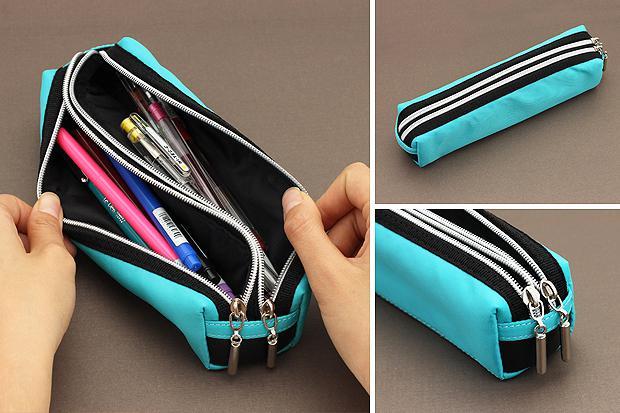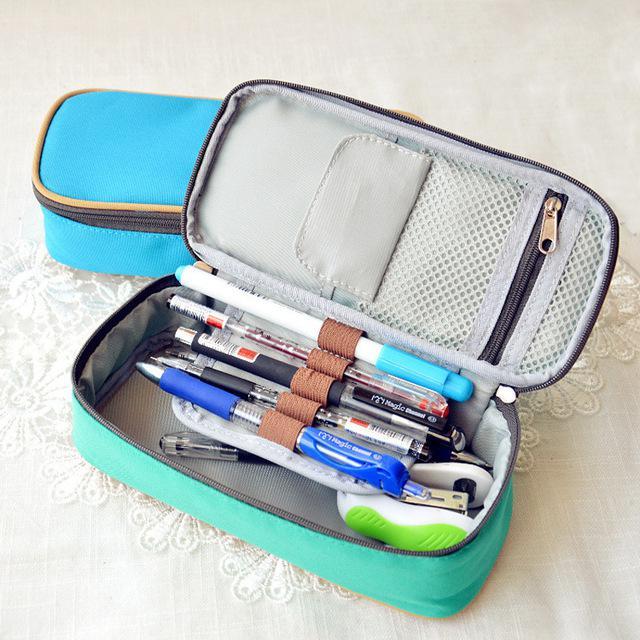The first image is the image on the left, the second image is the image on the right. Given the left and right images, does the statement "Each image contains an open turquoise blue pencil box." hold true? Answer yes or no. Yes. 